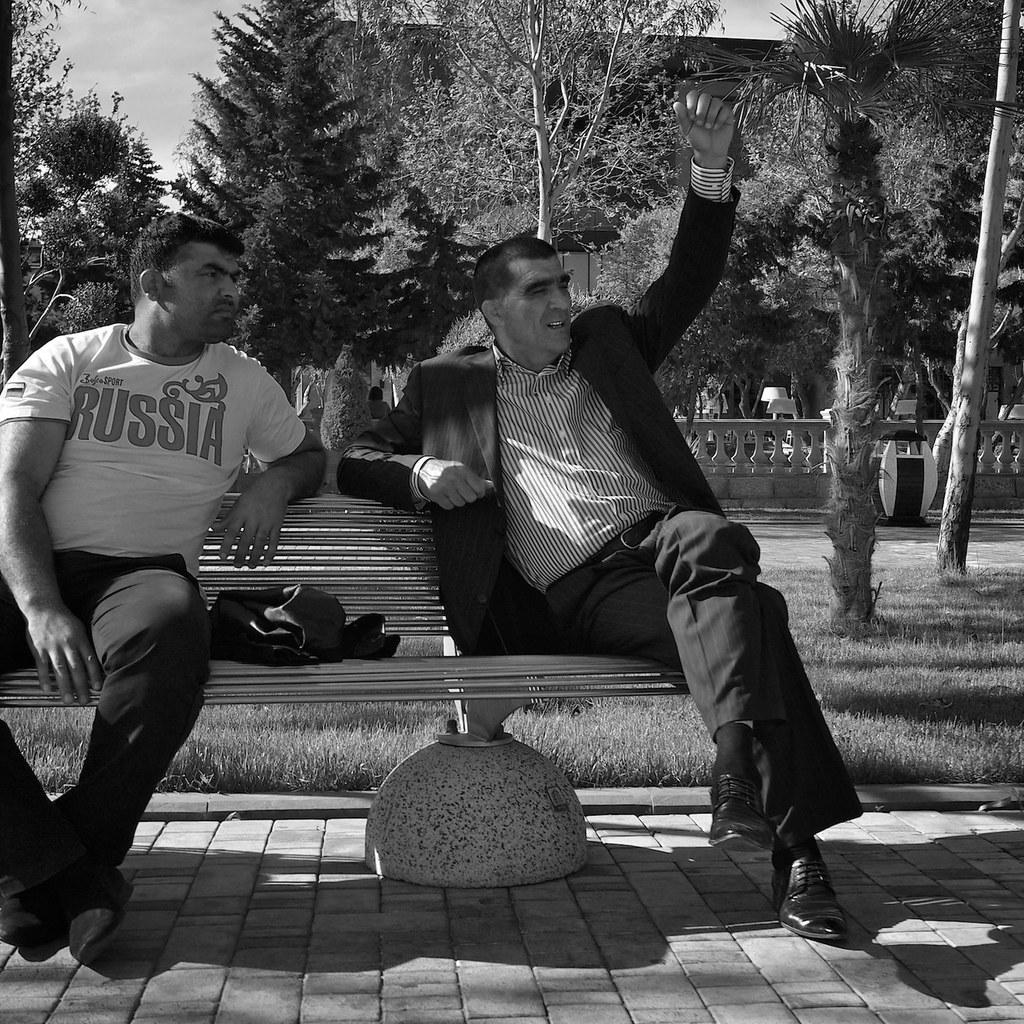How many people are in the image? There are two men in the image. What are the men doing in the image? The men are seated on a bench. What can be seen in the background of the image? There are trees visible in the image. What color is the zebra in the image? There is no zebra present in the image. 